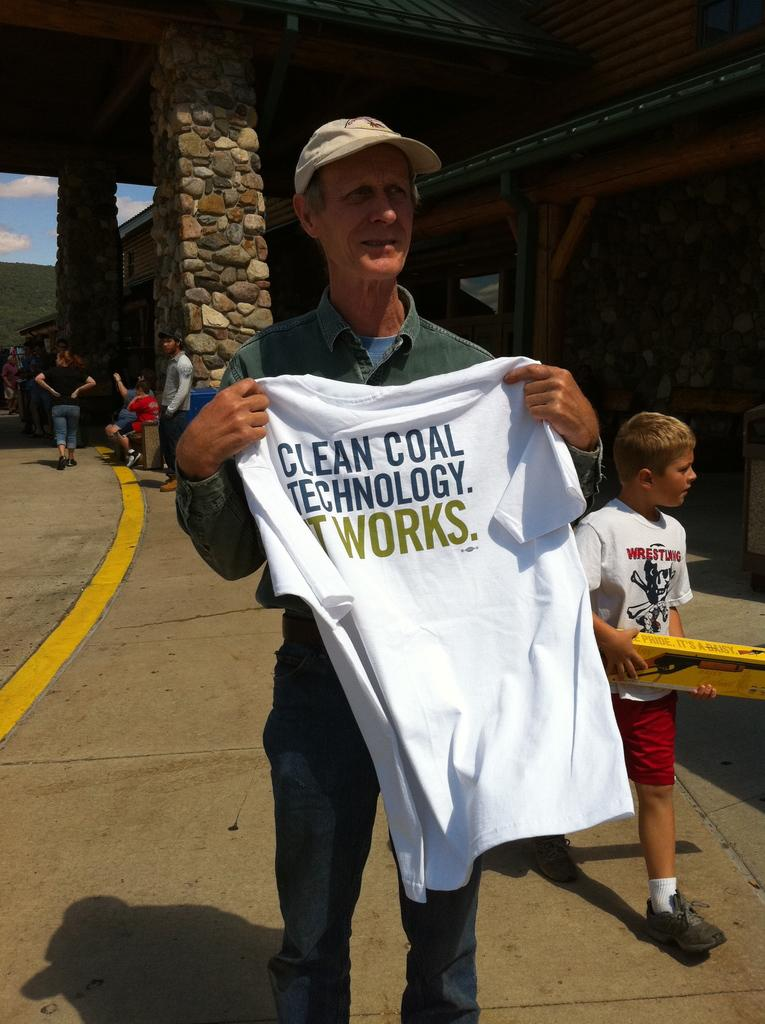<image>
Render a clear and concise summary of the photo. Man holding a white shirt which says "Clean Coal Technology'. 